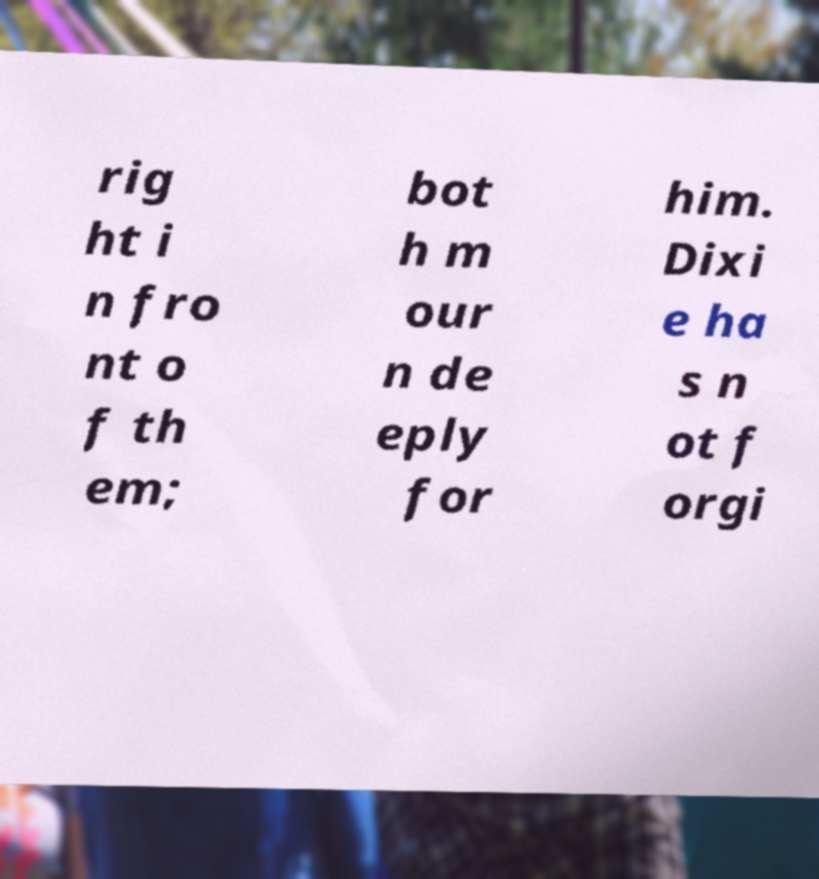For documentation purposes, I need the text within this image transcribed. Could you provide that? rig ht i n fro nt o f th em; bot h m our n de eply for him. Dixi e ha s n ot f orgi 